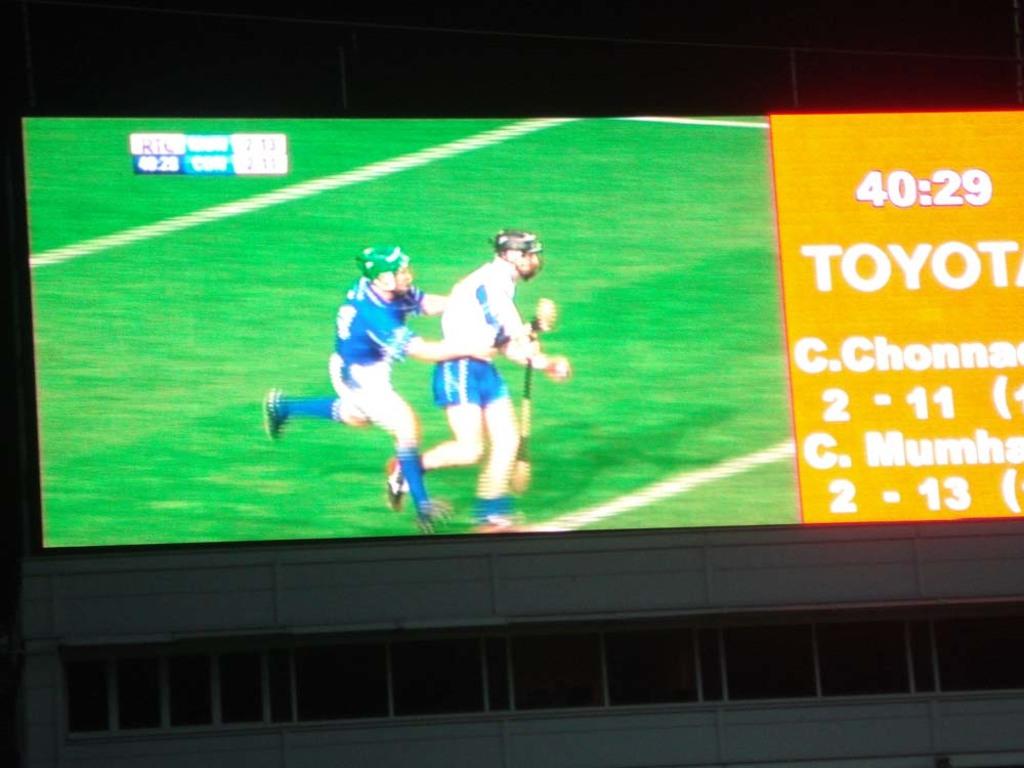What time is left in the game?
Keep it short and to the point. 40:29. What time is on the board?
Your response must be concise. 40:29. 